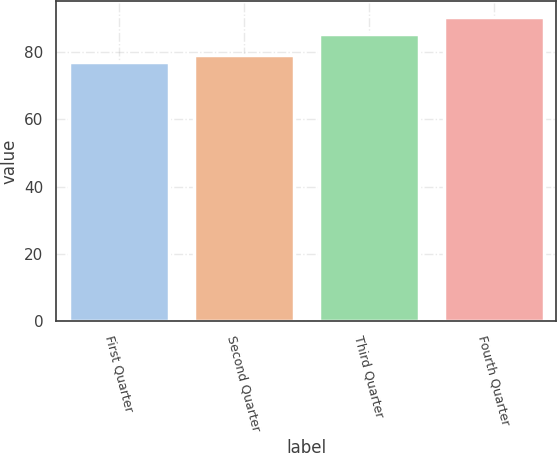<chart> <loc_0><loc_0><loc_500><loc_500><bar_chart><fcel>First Quarter<fcel>Second Quarter<fcel>Third Quarter<fcel>Fourth Quarter<nl><fcel>76.98<fcel>79.13<fcel>85.45<fcel>90.47<nl></chart> 